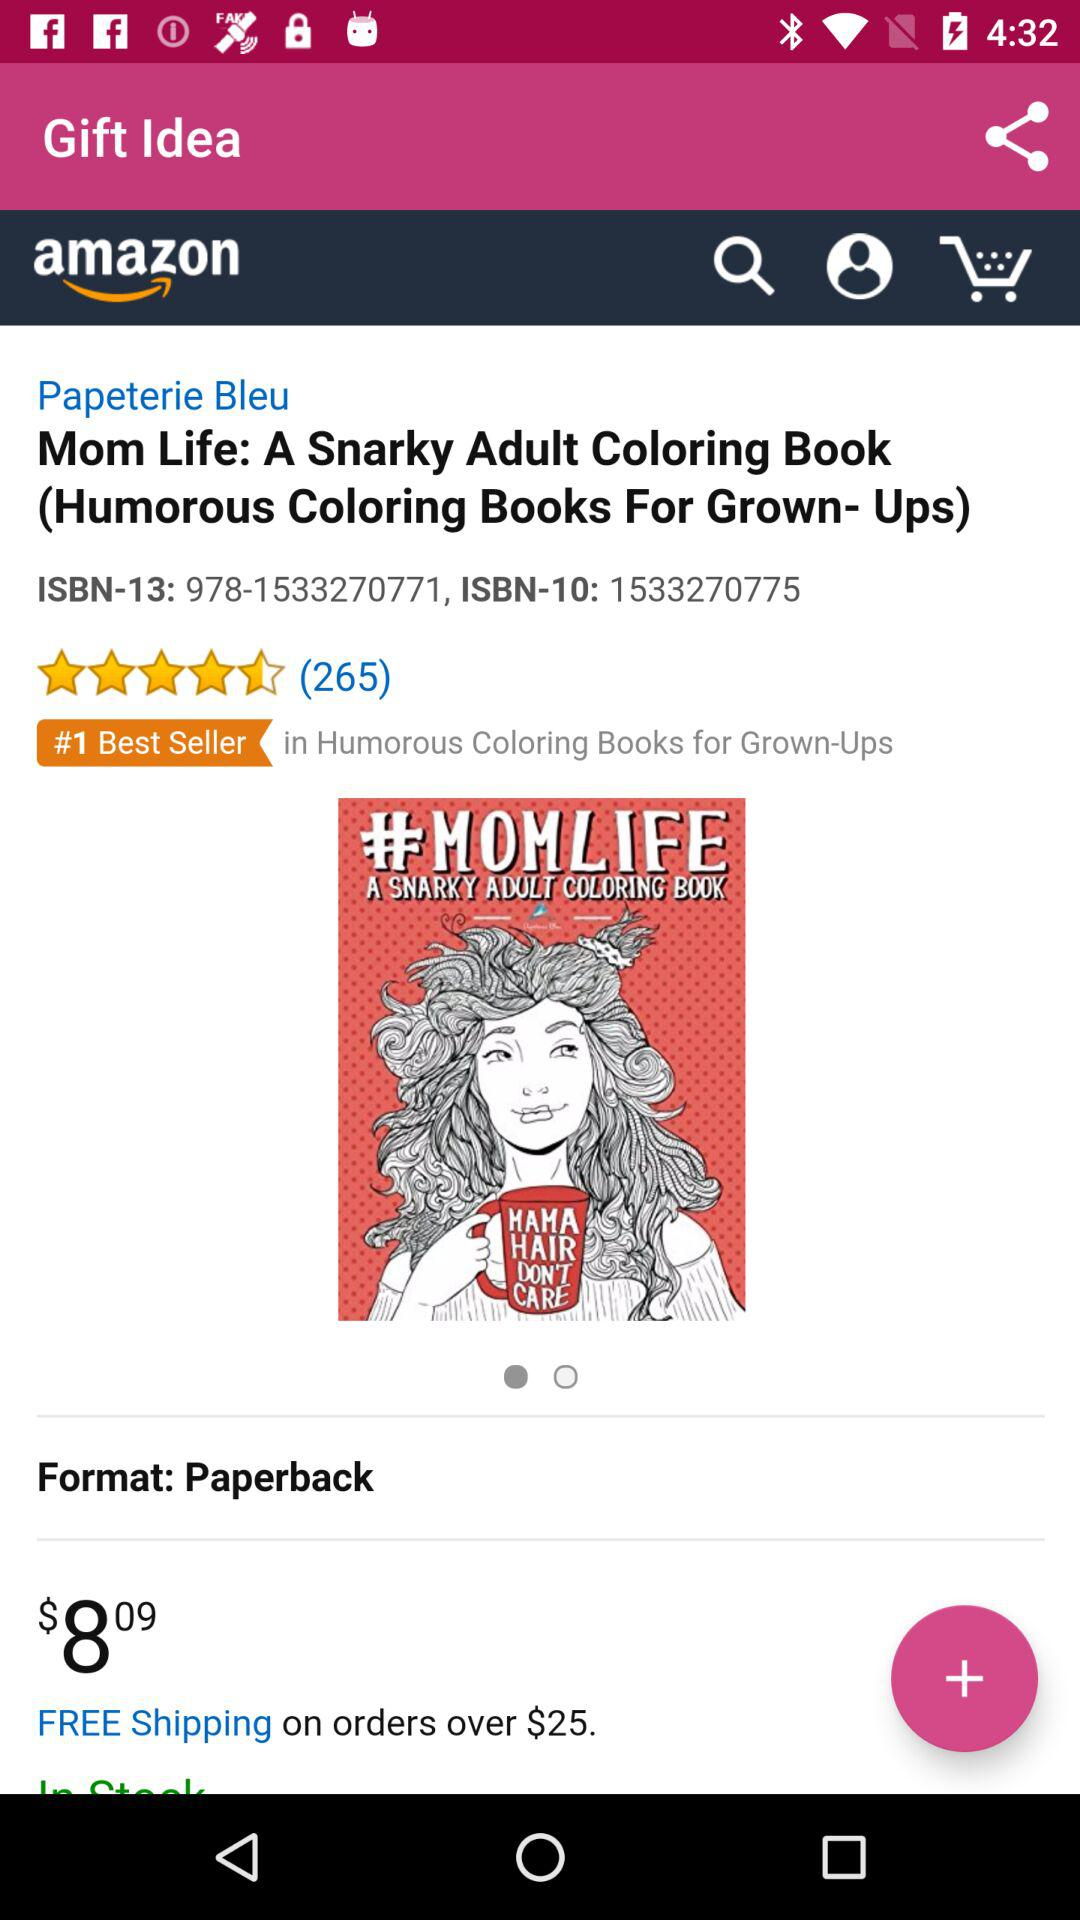What is the price of "Mom Life: A Snarky Adult Coloring Book"? The price is $8.09. 